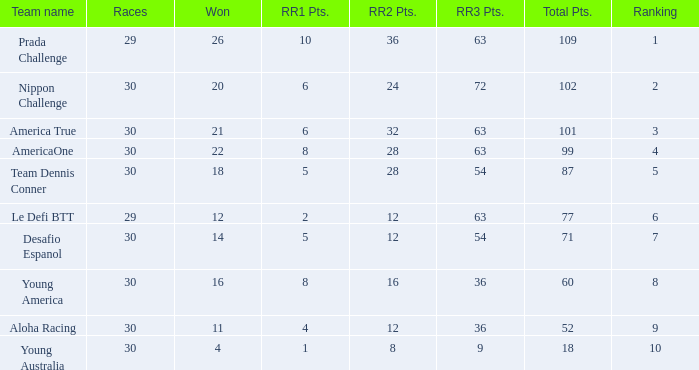Name the min total pts for team dennis conner 87.0. 